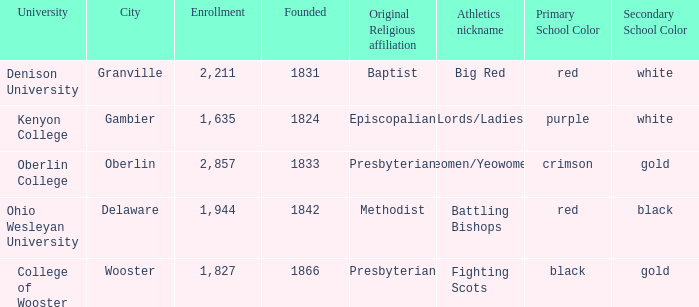What religious affiliation did the athletes nicknamed lords/ladies have? (Originally Episcopalian). 